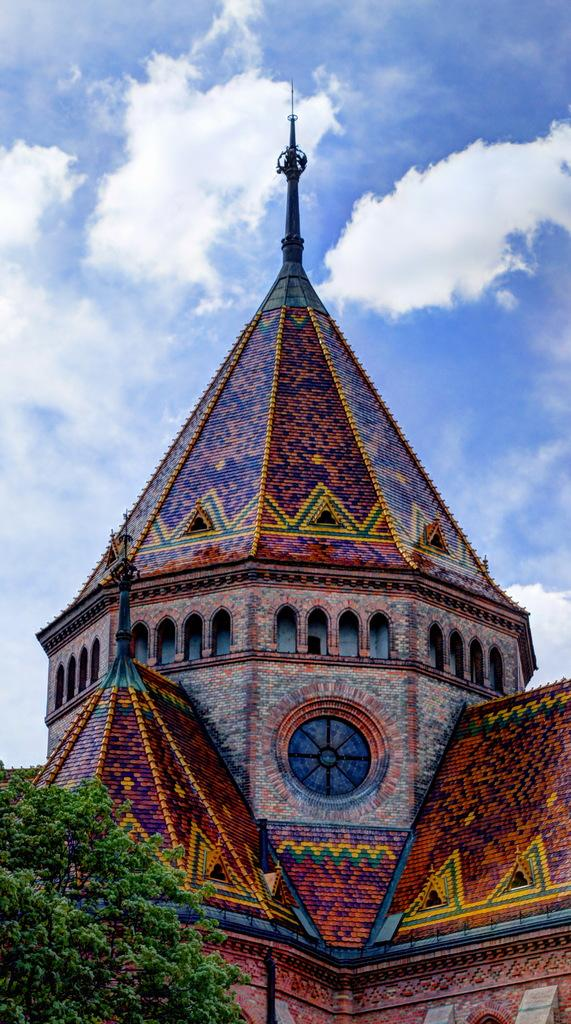What type of structure can be seen in the image? There is a building in the image. What natural element is present in the image? There is a tree in the image. What type of skirt is the person wearing in the image? There is no person present in the image, so it is not possible to determine what type of skirt they might be wearing. 